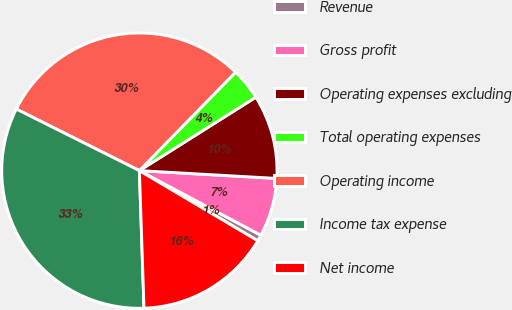Convert chart. <chart><loc_0><loc_0><loc_500><loc_500><pie_chart><fcel>Revenue<fcel>Gross profit<fcel>Operating expenses excluding<fcel>Total operating expenses<fcel>Operating income<fcel>Income tax expense<fcel>Net income<nl><fcel>0.74%<fcel>6.87%<fcel>9.86%<fcel>3.73%<fcel>29.93%<fcel>32.92%<fcel>15.95%<nl></chart> 